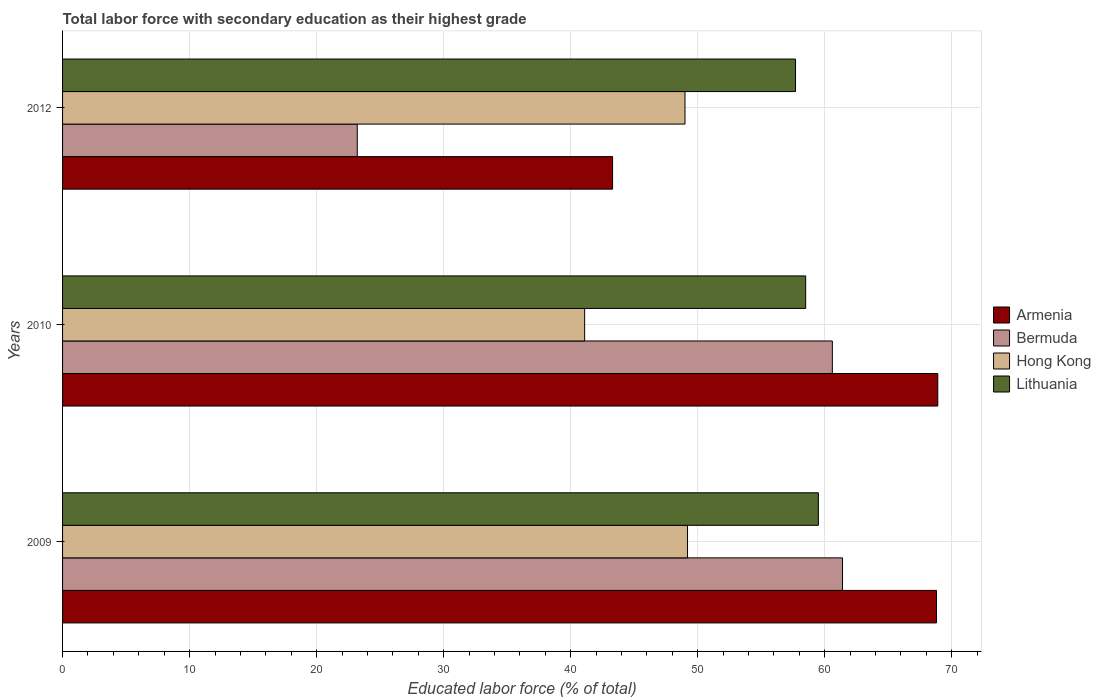How many different coloured bars are there?
Your answer should be very brief. 4. How many groups of bars are there?
Provide a succinct answer. 3. Are the number of bars per tick equal to the number of legend labels?
Your answer should be very brief. Yes. Are the number of bars on each tick of the Y-axis equal?
Make the answer very short. Yes. How many bars are there on the 1st tick from the top?
Your response must be concise. 4. What is the label of the 2nd group of bars from the top?
Make the answer very short. 2010. In how many cases, is the number of bars for a given year not equal to the number of legend labels?
Keep it short and to the point. 0. What is the percentage of total labor force with primary education in Armenia in 2009?
Keep it short and to the point. 68.8. Across all years, what is the maximum percentage of total labor force with primary education in Hong Kong?
Your answer should be very brief. 49.2. Across all years, what is the minimum percentage of total labor force with primary education in Armenia?
Make the answer very short. 43.3. In which year was the percentage of total labor force with primary education in Armenia minimum?
Give a very brief answer. 2012. What is the total percentage of total labor force with primary education in Lithuania in the graph?
Your answer should be compact. 175.7. What is the difference between the percentage of total labor force with primary education in Lithuania in 2010 and that in 2012?
Offer a very short reply. 0.8. What is the difference between the percentage of total labor force with primary education in Lithuania in 2010 and the percentage of total labor force with primary education in Hong Kong in 2009?
Offer a terse response. 9.3. What is the average percentage of total labor force with primary education in Hong Kong per year?
Your answer should be compact. 46.43. In the year 2009, what is the difference between the percentage of total labor force with primary education in Bermuda and percentage of total labor force with primary education in Lithuania?
Ensure brevity in your answer.  1.9. In how many years, is the percentage of total labor force with primary education in Hong Kong greater than 34 %?
Provide a succinct answer. 3. What is the ratio of the percentage of total labor force with primary education in Bermuda in 2009 to that in 2012?
Offer a very short reply. 2.65. Is the difference between the percentage of total labor force with primary education in Bermuda in 2010 and 2012 greater than the difference between the percentage of total labor force with primary education in Lithuania in 2010 and 2012?
Offer a very short reply. Yes. What is the difference between the highest and the second highest percentage of total labor force with primary education in Armenia?
Ensure brevity in your answer.  0.1. What is the difference between the highest and the lowest percentage of total labor force with primary education in Bermuda?
Ensure brevity in your answer.  38.2. Is the sum of the percentage of total labor force with primary education in Lithuania in 2010 and 2012 greater than the maximum percentage of total labor force with primary education in Bermuda across all years?
Offer a very short reply. Yes. What does the 3rd bar from the top in 2010 represents?
Offer a terse response. Bermuda. What does the 4th bar from the bottom in 2010 represents?
Your answer should be very brief. Lithuania. Is it the case that in every year, the sum of the percentage of total labor force with primary education in Lithuania and percentage of total labor force with primary education in Armenia is greater than the percentage of total labor force with primary education in Bermuda?
Ensure brevity in your answer.  Yes. How many bars are there?
Your answer should be very brief. 12. Are all the bars in the graph horizontal?
Provide a succinct answer. Yes. What is the difference between two consecutive major ticks on the X-axis?
Offer a terse response. 10. Does the graph contain any zero values?
Your answer should be very brief. No. Does the graph contain grids?
Your answer should be compact. Yes. Where does the legend appear in the graph?
Keep it short and to the point. Center right. How many legend labels are there?
Provide a succinct answer. 4. What is the title of the graph?
Offer a very short reply. Total labor force with secondary education as their highest grade. Does "Mauritania" appear as one of the legend labels in the graph?
Your response must be concise. No. What is the label or title of the X-axis?
Your answer should be very brief. Educated labor force (% of total). What is the Educated labor force (% of total) of Armenia in 2009?
Your answer should be compact. 68.8. What is the Educated labor force (% of total) in Bermuda in 2009?
Make the answer very short. 61.4. What is the Educated labor force (% of total) of Hong Kong in 2009?
Keep it short and to the point. 49.2. What is the Educated labor force (% of total) in Lithuania in 2009?
Your response must be concise. 59.5. What is the Educated labor force (% of total) in Armenia in 2010?
Make the answer very short. 68.9. What is the Educated labor force (% of total) in Bermuda in 2010?
Offer a very short reply. 60.6. What is the Educated labor force (% of total) of Hong Kong in 2010?
Offer a terse response. 41.1. What is the Educated labor force (% of total) of Lithuania in 2010?
Give a very brief answer. 58.5. What is the Educated labor force (% of total) of Armenia in 2012?
Your response must be concise. 43.3. What is the Educated labor force (% of total) of Bermuda in 2012?
Offer a terse response. 23.2. What is the Educated labor force (% of total) of Hong Kong in 2012?
Provide a short and direct response. 49. What is the Educated labor force (% of total) of Lithuania in 2012?
Make the answer very short. 57.7. Across all years, what is the maximum Educated labor force (% of total) of Armenia?
Ensure brevity in your answer.  68.9. Across all years, what is the maximum Educated labor force (% of total) of Bermuda?
Offer a very short reply. 61.4. Across all years, what is the maximum Educated labor force (% of total) of Hong Kong?
Keep it short and to the point. 49.2. Across all years, what is the maximum Educated labor force (% of total) of Lithuania?
Give a very brief answer. 59.5. Across all years, what is the minimum Educated labor force (% of total) in Armenia?
Make the answer very short. 43.3. Across all years, what is the minimum Educated labor force (% of total) in Bermuda?
Provide a short and direct response. 23.2. Across all years, what is the minimum Educated labor force (% of total) of Hong Kong?
Offer a very short reply. 41.1. Across all years, what is the minimum Educated labor force (% of total) of Lithuania?
Offer a very short reply. 57.7. What is the total Educated labor force (% of total) of Armenia in the graph?
Your answer should be compact. 181. What is the total Educated labor force (% of total) in Bermuda in the graph?
Your answer should be compact. 145.2. What is the total Educated labor force (% of total) in Hong Kong in the graph?
Provide a short and direct response. 139.3. What is the total Educated labor force (% of total) of Lithuania in the graph?
Your response must be concise. 175.7. What is the difference between the Educated labor force (% of total) of Armenia in 2009 and that in 2010?
Your response must be concise. -0.1. What is the difference between the Educated labor force (% of total) of Bermuda in 2009 and that in 2010?
Your response must be concise. 0.8. What is the difference between the Educated labor force (% of total) in Hong Kong in 2009 and that in 2010?
Give a very brief answer. 8.1. What is the difference between the Educated labor force (% of total) in Armenia in 2009 and that in 2012?
Keep it short and to the point. 25.5. What is the difference between the Educated labor force (% of total) of Bermuda in 2009 and that in 2012?
Offer a terse response. 38.2. What is the difference between the Educated labor force (% of total) in Hong Kong in 2009 and that in 2012?
Provide a short and direct response. 0.2. What is the difference between the Educated labor force (% of total) in Lithuania in 2009 and that in 2012?
Offer a very short reply. 1.8. What is the difference between the Educated labor force (% of total) of Armenia in 2010 and that in 2012?
Provide a short and direct response. 25.6. What is the difference between the Educated labor force (% of total) of Bermuda in 2010 and that in 2012?
Make the answer very short. 37.4. What is the difference between the Educated labor force (% of total) in Hong Kong in 2010 and that in 2012?
Give a very brief answer. -7.9. What is the difference between the Educated labor force (% of total) in Lithuania in 2010 and that in 2012?
Your answer should be very brief. 0.8. What is the difference between the Educated labor force (% of total) in Armenia in 2009 and the Educated labor force (% of total) in Bermuda in 2010?
Make the answer very short. 8.2. What is the difference between the Educated labor force (% of total) of Armenia in 2009 and the Educated labor force (% of total) of Hong Kong in 2010?
Provide a succinct answer. 27.7. What is the difference between the Educated labor force (% of total) in Bermuda in 2009 and the Educated labor force (% of total) in Hong Kong in 2010?
Make the answer very short. 20.3. What is the difference between the Educated labor force (% of total) of Hong Kong in 2009 and the Educated labor force (% of total) of Lithuania in 2010?
Keep it short and to the point. -9.3. What is the difference between the Educated labor force (% of total) in Armenia in 2009 and the Educated labor force (% of total) in Bermuda in 2012?
Your response must be concise. 45.6. What is the difference between the Educated labor force (% of total) of Armenia in 2009 and the Educated labor force (% of total) of Hong Kong in 2012?
Offer a very short reply. 19.8. What is the difference between the Educated labor force (% of total) of Bermuda in 2009 and the Educated labor force (% of total) of Hong Kong in 2012?
Provide a succinct answer. 12.4. What is the difference between the Educated labor force (% of total) of Bermuda in 2009 and the Educated labor force (% of total) of Lithuania in 2012?
Provide a short and direct response. 3.7. What is the difference between the Educated labor force (% of total) of Hong Kong in 2009 and the Educated labor force (% of total) of Lithuania in 2012?
Keep it short and to the point. -8.5. What is the difference between the Educated labor force (% of total) of Armenia in 2010 and the Educated labor force (% of total) of Bermuda in 2012?
Provide a succinct answer. 45.7. What is the difference between the Educated labor force (% of total) in Bermuda in 2010 and the Educated labor force (% of total) in Hong Kong in 2012?
Your answer should be compact. 11.6. What is the difference between the Educated labor force (% of total) of Bermuda in 2010 and the Educated labor force (% of total) of Lithuania in 2012?
Ensure brevity in your answer.  2.9. What is the difference between the Educated labor force (% of total) of Hong Kong in 2010 and the Educated labor force (% of total) of Lithuania in 2012?
Your answer should be compact. -16.6. What is the average Educated labor force (% of total) in Armenia per year?
Give a very brief answer. 60.33. What is the average Educated labor force (% of total) of Bermuda per year?
Provide a short and direct response. 48.4. What is the average Educated labor force (% of total) of Hong Kong per year?
Ensure brevity in your answer.  46.43. What is the average Educated labor force (% of total) of Lithuania per year?
Keep it short and to the point. 58.57. In the year 2009, what is the difference between the Educated labor force (% of total) of Armenia and Educated labor force (% of total) of Hong Kong?
Ensure brevity in your answer.  19.6. In the year 2009, what is the difference between the Educated labor force (% of total) in Bermuda and Educated labor force (% of total) in Lithuania?
Keep it short and to the point. 1.9. In the year 2009, what is the difference between the Educated labor force (% of total) in Hong Kong and Educated labor force (% of total) in Lithuania?
Offer a terse response. -10.3. In the year 2010, what is the difference between the Educated labor force (% of total) of Armenia and Educated labor force (% of total) of Hong Kong?
Provide a succinct answer. 27.8. In the year 2010, what is the difference between the Educated labor force (% of total) of Armenia and Educated labor force (% of total) of Lithuania?
Give a very brief answer. 10.4. In the year 2010, what is the difference between the Educated labor force (% of total) in Bermuda and Educated labor force (% of total) in Hong Kong?
Give a very brief answer. 19.5. In the year 2010, what is the difference between the Educated labor force (% of total) of Bermuda and Educated labor force (% of total) of Lithuania?
Provide a short and direct response. 2.1. In the year 2010, what is the difference between the Educated labor force (% of total) in Hong Kong and Educated labor force (% of total) in Lithuania?
Your response must be concise. -17.4. In the year 2012, what is the difference between the Educated labor force (% of total) in Armenia and Educated labor force (% of total) in Bermuda?
Make the answer very short. 20.1. In the year 2012, what is the difference between the Educated labor force (% of total) of Armenia and Educated labor force (% of total) of Lithuania?
Make the answer very short. -14.4. In the year 2012, what is the difference between the Educated labor force (% of total) in Bermuda and Educated labor force (% of total) in Hong Kong?
Your answer should be very brief. -25.8. In the year 2012, what is the difference between the Educated labor force (% of total) in Bermuda and Educated labor force (% of total) in Lithuania?
Provide a short and direct response. -34.5. In the year 2012, what is the difference between the Educated labor force (% of total) of Hong Kong and Educated labor force (% of total) of Lithuania?
Your response must be concise. -8.7. What is the ratio of the Educated labor force (% of total) in Armenia in 2009 to that in 2010?
Ensure brevity in your answer.  1. What is the ratio of the Educated labor force (% of total) in Bermuda in 2009 to that in 2010?
Make the answer very short. 1.01. What is the ratio of the Educated labor force (% of total) in Hong Kong in 2009 to that in 2010?
Make the answer very short. 1.2. What is the ratio of the Educated labor force (% of total) of Lithuania in 2009 to that in 2010?
Your answer should be compact. 1.02. What is the ratio of the Educated labor force (% of total) in Armenia in 2009 to that in 2012?
Ensure brevity in your answer.  1.59. What is the ratio of the Educated labor force (% of total) of Bermuda in 2009 to that in 2012?
Keep it short and to the point. 2.65. What is the ratio of the Educated labor force (% of total) of Lithuania in 2009 to that in 2012?
Make the answer very short. 1.03. What is the ratio of the Educated labor force (% of total) in Armenia in 2010 to that in 2012?
Keep it short and to the point. 1.59. What is the ratio of the Educated labor force (% of total) in Bermuda in 2010 to that in 2012?
Your response must be concise. 2.61. What is the ratio of the Educated labor force (% of total) in Hong Kong in 2010 to that in 2012?
Ensure brevity in your answer.  0.84. What is the ratio of the Educated labor force (% of total) in Lithuania in 2010 to that in 2012?
Offer a terse response. 1.01. What is the difference between the highest and the second highest Educated labor force (% of total) of Armenia?
Offer a terse response. 0.1. What is the difference between the highest and the lowest Educated labor force (% of total) of Armenia?
Provide a succinct answer. 25.6. What is the difference between the highest and the lowest Educated labor force (% of total) in Bermuda?
Give a very brief answer. 38.2. What is the difference between the highest and the lowest Educated labor force (% of total) of Hong Kong?
Your answer should be compact. 8.1. What is the difference between the highest and the lowest Educated labor force (% of total) of Lithuania?
Offer a very short reply. 1.8. 